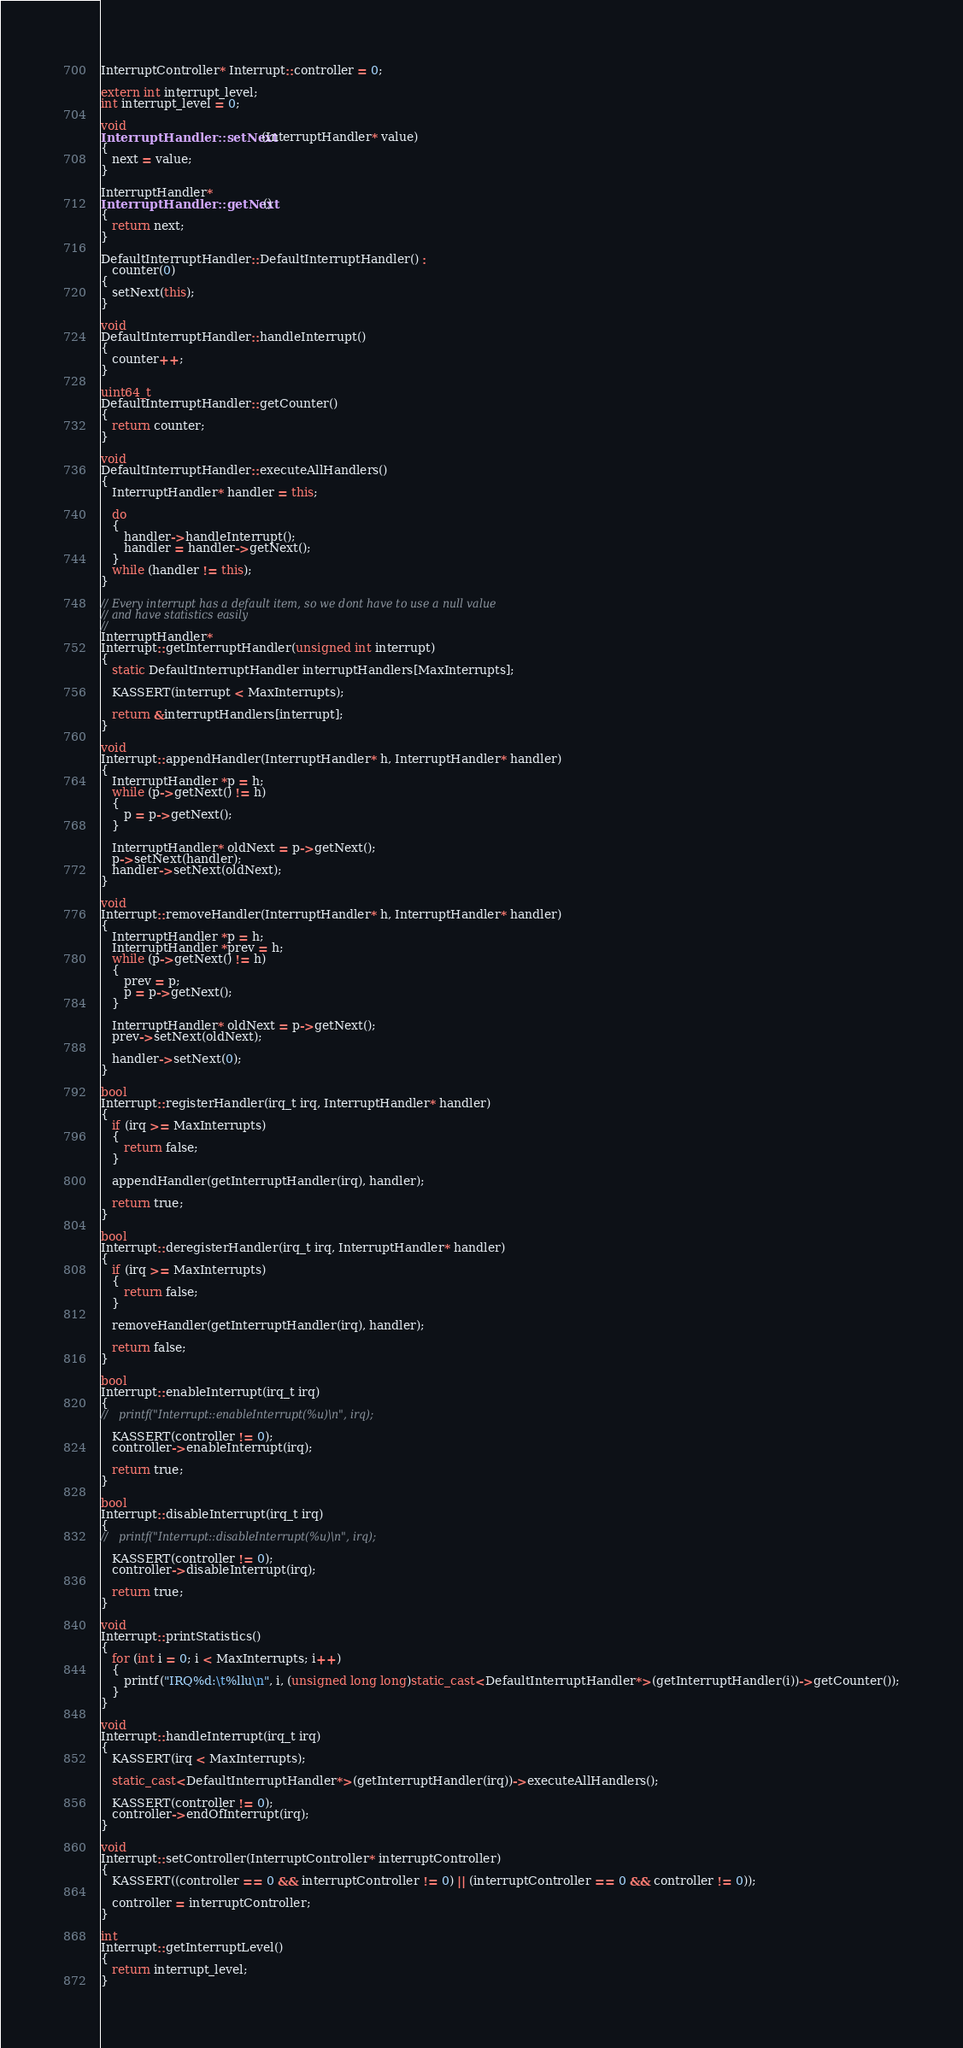Convert code to text. <code><loc_0><loc_0><loc_500><loc_500><_C++_>InterruptController* Interrupt::controller = 0;

extern int interrupt_level;
int interrupt_level = 0;

void
InterruptHandler::setNext(InterruptHandler* value)
{
   next = value;
}

InterruptHandler*
InterruptHandler::getNext()
{
   return next;
}

DefaultInterruptHandler::DefaultInterruptHandler() :
   counter(0)
{
   setNext(this);
}

void
DefaultInterruptHandler::handleInterrupt()
{
   counter++;
}

uint64_t
DefaultInterruptHandler::getCounter()
{
   return counter;
}

void
DefaultInterruptHandler::executeAllHandlers()
{
   InterruptHandler* handler = this;

   do
   {
      handler->handleInterrupt();
      handler = handler->getNext();
   }
   while (handler != this);
}

// Every interrupt has a default item, so we dont have to use a null value
// and have statistics easily
//
InterruptHandler*
Interrupt::getInterruptHandler(unsigned int interrupt)
{
   static DefaultInterruptHandler interruptHandlers[MaxInterrupts];

   KASSERT(interrupt < MaxInterrupts);

   return &interruptHandlers[interrupt];
}

void
Interrupt::appendHandler(InterruptHandler* h, InterruptHandler* handler)
{
   InterruptHandler *p = h;
   while (p->getNext() != h)
   {
      p = p->getNext();
   }

   InterruptHandler* oldNext = p->getNext();
   p->setNext(handler);
   handler->setNext(oldNext);
}

void
Interrupt::removeHandler(InterruptHandler* h, InterruptHandler* handler)
{
   InterruptHandler *p = h;
   InterruptHandler *prev = h;
   while (p->getNext() != h)
   {
      prev = p;
      p = p->getNext();
   }

   InterruptHandler* oldNext = p->getNext();
   prev->setNext(oldNext);

   handler->setNext(0);
}

bool
Interrupt::registerHandler(irq_t irq, InterruptHandler* handler)
{
   if (irq >= MaxInterrupts)
   {
      return false;
   }

   appendHandler(getInterruptHandler(irq), handler);

   return true;
}

bool
Interrupt::deregisterHandler(irq_t irq, InterruptHandler* handler)
{
   if (irq >= MaxInterrupts)
   {
      return false;
   }

   removeHandler(getInterruptHandler(irq), handler);

   return false;
}

bool
Interrupt::enableInterrupt(irq_t irq)
{
//   printf("Interrupt::enableInterrupt(%u)\n", irq);

   KASSERT(controller != 0);
   controller->enableInterrupt(irq);

   return true;
}

bool
Interrupt::disableInterrupt(irq_t irq)
{
//   printf("Interrupt::disableInterrupt(%u)\n", irq);

   KASSERT(controller != 0);
   controller->disableInterrupt(irq);

   return true;
}

void
Interrupt::printStatistics()
{
   for (int i = 0; i < MaxInterrupts; i++)
   {
      printf("IRQ%d:\t%llu\n", i, (unsigned long long)static_cast<DefaultInterruptHandler*>(getInterruptHandler(i))->getCounter());
   }
}

void
Interrupt::handleInterrupt(irq_t irq)
{
   KASSERT(irq < MaxInterrupts);

   static_cast<DefaultInterruptHandler*>(getInterruptHandler(irq))->executeAllHandlers();

   KASSERT(controller != 0);
   controller->endOfInterrupt(irq);
}

void
Interrupt::setController(InterruptController* interruptController)
{
   KASSERT((controller == 0 && interruptController != 0) || (interruptController == 0 && controller != 0));

   controller = interruptController;
}

int
Interrupt::getInterruptLevel()
{
   return interrupt_level;
}
</code> 